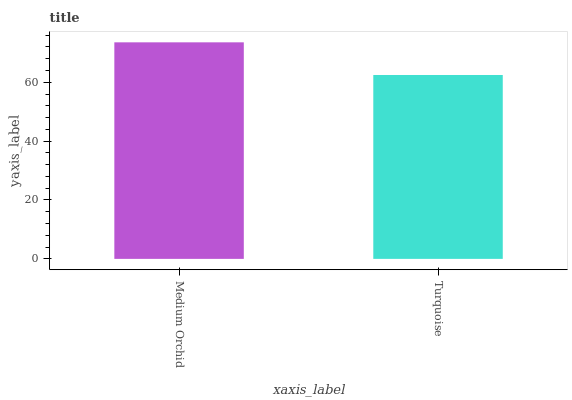Is Turquoise the minimum?
Answer yes or no. Yes. Is Medium Orchid the maximum?
Answer yes or no. Yes. Is Turquoise the maximum?
Answer yes or no. No. Is Medium Orchid greater than Turquoise?
Answer yes or no. Yes. Is Turquoise less than Medium Orchid?
Answer yes or no. Yes. Is Turquoise greater than Medium Orchid?
Answer yes or no. No. Is Medium Orchid less than Turquoise?
Answer yes or no. No. Is Medium Orchid the high median?
Answer yes or no. Yes. Is Turquoise the low median?
Answer yes or no. Yes. Is Turquoise the high median?
Answer yes or no. No. Is Medium Orchid the low median?
Answer yes or no. No. 